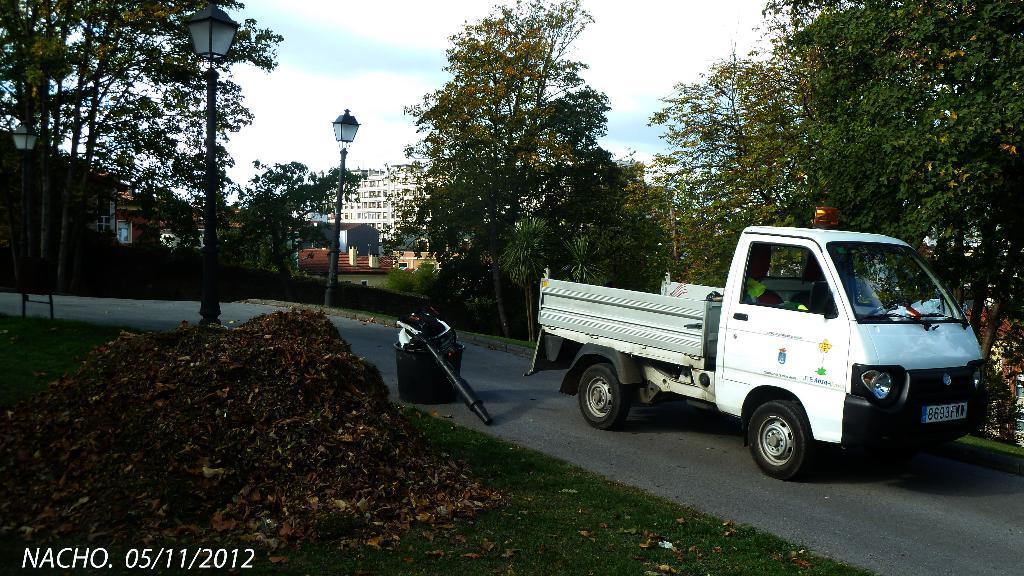How would you summarize this image in a sentence or two? In this image there is a vehicle on the road and there is a tub on the road. There are leaves, light poles on the grass. At the back there are trees and buildings. At the top there is a sky. 